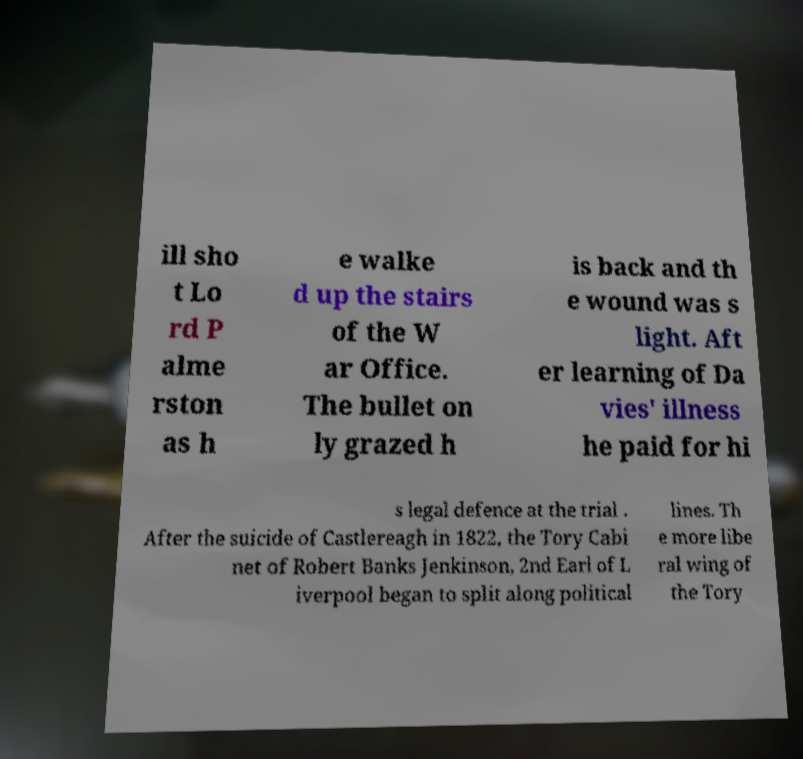Could you extract and type out the text from this image? ill sho t Lo rd P alme rston as h e walke d up the stairs of the W ar Office. The bullet on ly grazed h is back and th e wound was s light. Aft er learning of Da vies' illness he paid for hi s legal defence at the trial . After the suicide of Castlereagh in 1822, the Tory Cabi net of Robert Banks Jenkinson, 2nd Earl of L iverpool began to split along political lines. Th e more libe ral wing of the Tory 